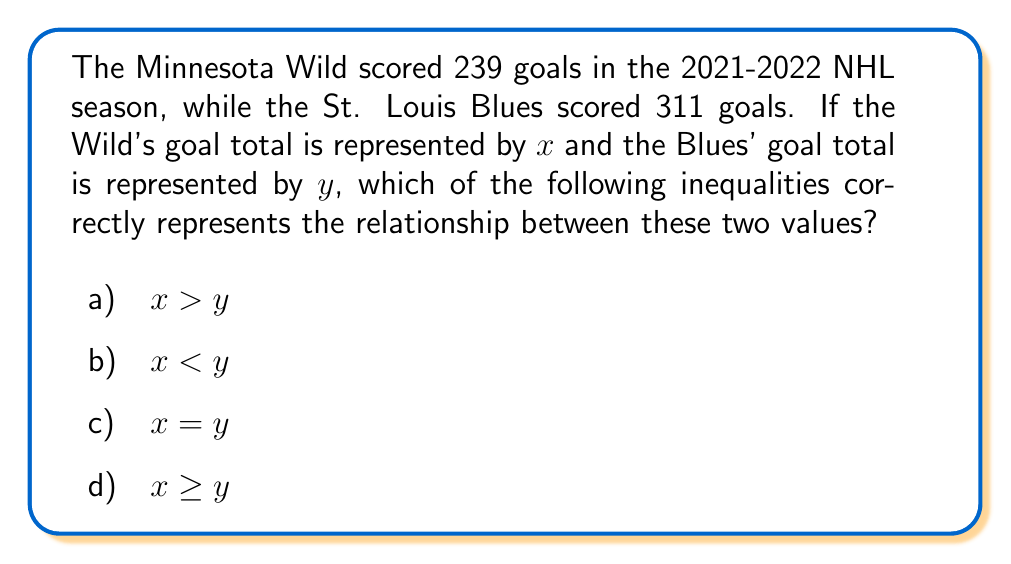Help me with this question. Let's approach this step-by-step:

1) We are given that:
   $x = 239$ (Minnesota Wild's goals)
   $y = 311$ (St. Louis Blues' goals)

2) To determine the correct inequality, we need to compare these two values:

   $239 < 311$

3) This shows that the Wild scored fewer goals than the Blues.

4) In the context of inequalities:
   - $<$ means "less than"
   - $>$ means "greater than"
   - $=$ means "equal to"
   - $\geq$ means "greater than or equal to"

5) Since $x$ (239) is less than $y$ (311), the correct inequality is $x < y$.

6) This corresponds to option b) in the given choices.
Answer: b) $x < y$ 